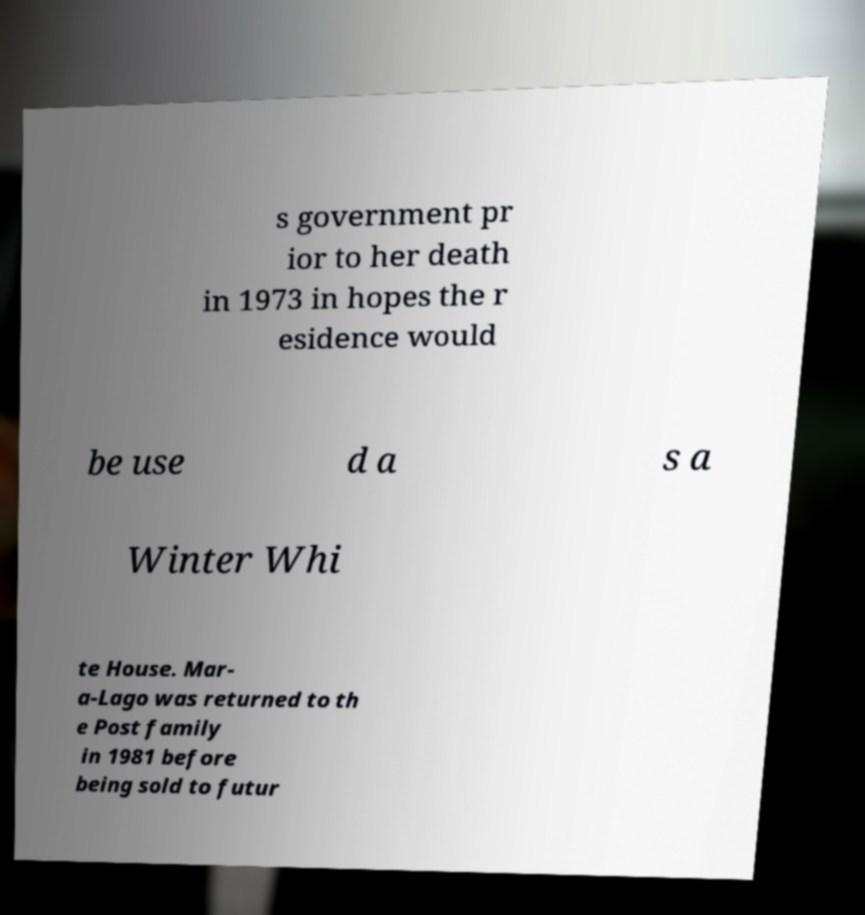Could you extract and type out the text from this image? s government pr ior to her death in 1973 in hopes the r esidence would be use d a s a Winter Whi te House. Mar- a-Lago was returned to th e Post family in 1981 before being sold to futur 